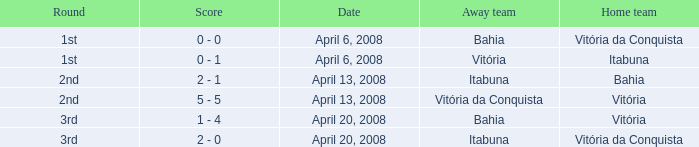What is the name of the home team on April 13, 2008 when Itabuna was the away team? Bahia. 